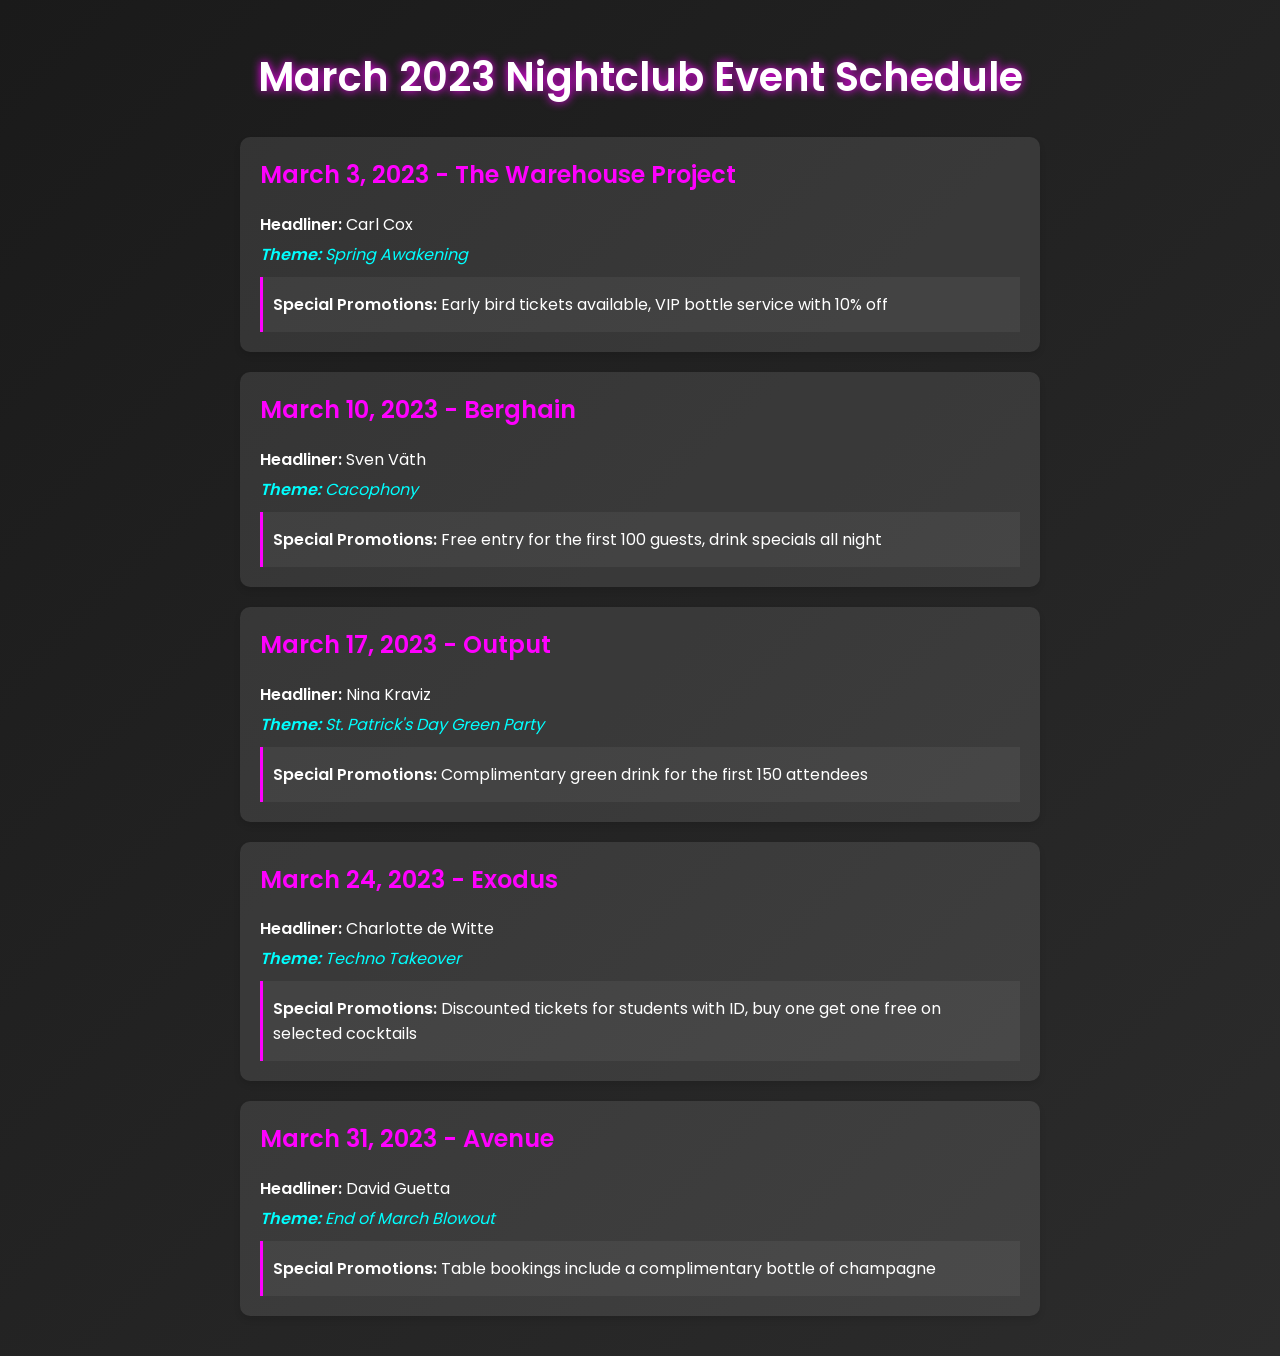What is the headliner for March 3, 2023? The headliner for March 3, 2023, is mentioned in the event details.
Answer: Carl Cox What theme is associated with March 10, 2023? The theme can be found in the section detailing the March 10 event.
Answer: Cacophony How many guests receive free entry on March 10, 2023? This information is found in the promotions for the March 10 event.
Answer: 100 Which DJ is performing on March 31, 2023? The performing DJ is listed in the details of the March 31 event.
Answer: David Guetta What special promotion is offered on March 17, 2023? The special promotion can be located in the promotions section for that date.
Answer: Complimentary green drink for the first 150 attendees Which nightclub features the "Techno Takeover" theme? The theme is linked to the event details for the corresponding date.
Answer: Exodus What date is the "End of March Blowout" scheduled? The schedule provides a clear date for this specific event.
Answer: March 31, 2023 How many cocktails can you get buy one get one free on March 24, 2023? This information is found in the promotions that accompany the event on March 24.
Answer: Selected cocktails What is the venue for the event featuring Nina Kraviz? The venue is stated in the event details for March 17.
Answer: Output 